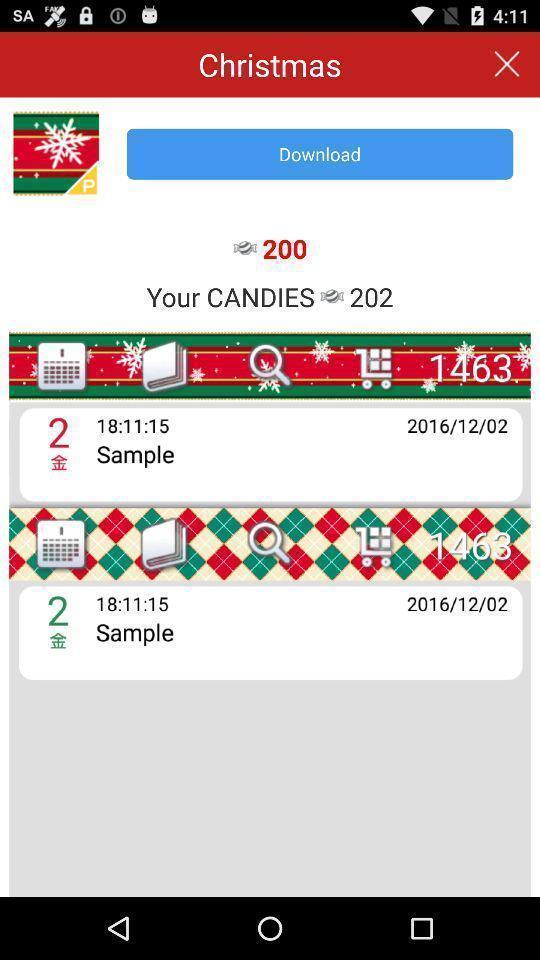Give me a narrative description of this picture. Page for writing notes in a dairy app. 